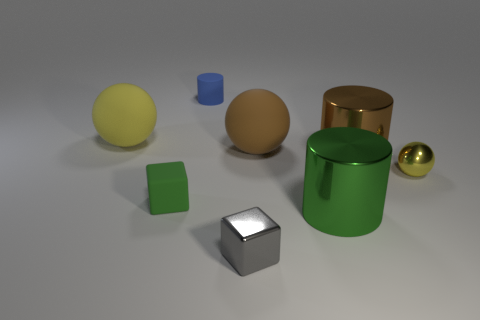Subtract all small balls. How many balls are left? 2 Add 2 small gray shiny balls. How many objects exist? 10 Subtract all gray cubes. How many cubes are left? 1 Subtract all brown cylinders. How many yellow balls are left? 2 Subtract 1 cylinders. How many cylinders are left? 2 Subtract all cylinders. How many objects are left? 5 Add 2 green metal things. How many green metal things are left? 3 Add 1 green blocks. How many green blocks exist? 2 Subtract 0 red blocks. How many objects are left? 8 Subtract all gray cubes. Subtract all brown spheres. How many cubes are left? 1 